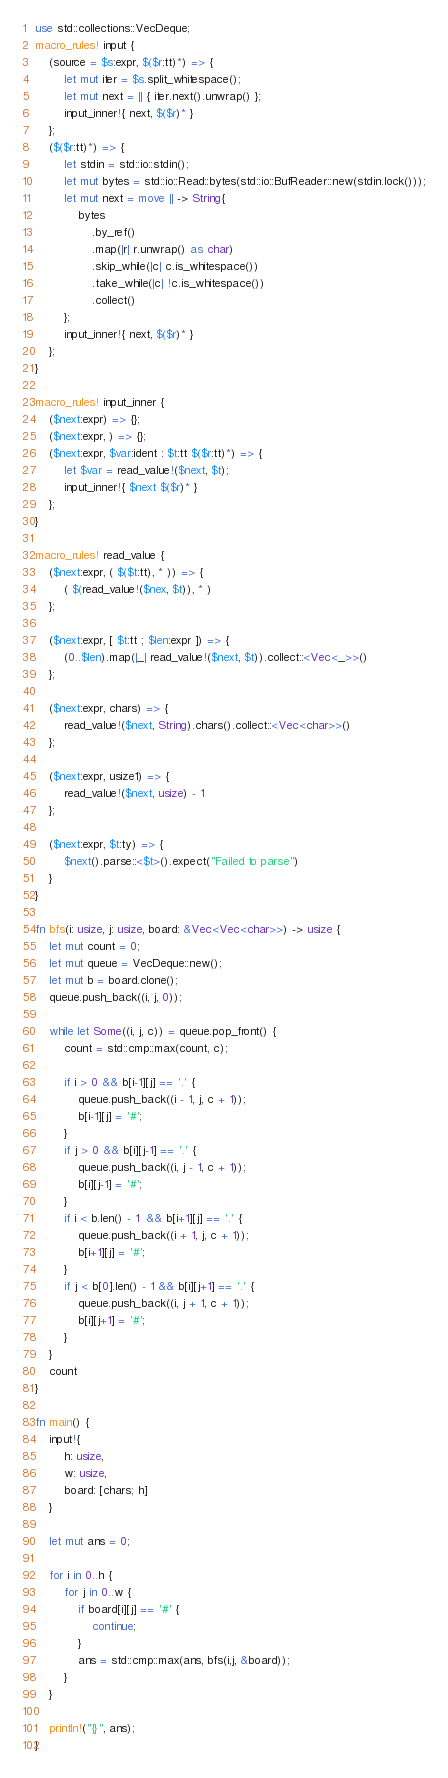Convert code to text. <code><loc_0><loc_0><loc_500><loc_500><_Rust_>use std::collections::VecDeque;
macro_rules! input {
    (source = $s:expr, $($r:tt)*) => {
        let mut iter = $s.split_whitespace();
        let mut next = || { iter.next().unwrap() };
        input_inner!{ next, $($r)* }
    };
    ($($r:tt)*) => {
        let stdin = std::io::stdin();
        let mut bytes = std::io::Read::bytes(std::io::BufReader::new(stdin.lock()));
        let mut next = move || -> String{
            bytes
                .by_ref()
                .map(|r| r.unwrap() as char)
                .skip_while(|c| c.is_whitespace())
                .take_while(|c| !c.is_whitespace())
                .collect()
        };
        input_inner!{ next, $($r)* }
    };
}

macro_rules! input_inner {
    ($next:expr) => {};
    ($next:expr, ) => {};
    ($next:expr, $var:ident : $t:tt $($r:tt)*) => {
        let $var = read_value!($next, $t);
        input_inner!{ $next $($r)* }
    };
}

macro_rules! read_value {
    ($next:expr, ( $($t:tt), * )) => {
        ( $(read_value!($nex, $t)), * )
    };

    ($next:expr, [ $t:tt ; $len:expr ]) => {
        (0..$len).map(|_| read_value!($next, $t)).collect::<Vec<_>>()
    };

    ($next:expr, chars) => {
        read_value!($next, String).chars().collect::<Vec<char>>()
    };

    ($next:expr, usize1) => {
        read_value!($next, usize) - 1
    };

    ($next:expr, $t:ty) => {
        $next().parse::<$t>().expect("Failed to parse")
    }
}

fn bfs(i: usize, j: usize, board: &Vec<Vec<char>>) -> usize {
    let mut count = 0;
    let mut queue = VecDeque::new();
    let mut b = board.clone();
    queue.push_back((i, j, 0));

    while let Some((i, j, c)) = queue.pop_front() {
        count = std::cmp::max(count, c);

        if i > 0 && b[i-1][j] == '.' {
            queue.push_back((i - 1, j, c + 1));
            b[i-1][j] = '#';
        }
        if j > 0 && b[i][j-1] == '.' {
            queue.push_back((i, j - 1, c + 1));
            b[i][j-1] = '#';
        }
        if i < b.len() - 1  && b[i+1][j] == '.' {
            queue.push_back((i + 1, j, c + 1));
            b[i+1][j] = '#';
        }
        if j < b[0].len() - 1 && b[i][j+1] == '.' {
            queue.push_back((i, j + 1, c + 1));
            b[i][j+1] = '#';
        }
    }
    count
}

fn main() {
    input!{
        h: usize,
        w: usize,
        board: [chars; h]
    }

    let mut ans = 0;

    for i in 0..h {
        for j in 0..w {
            if board[i][j] == '#' {
                continue;
            }
            ans = std::cmp::max(ans, bfs(i,j, &board));
        }
    }
    
    println!("{}", ans);
}</code> 